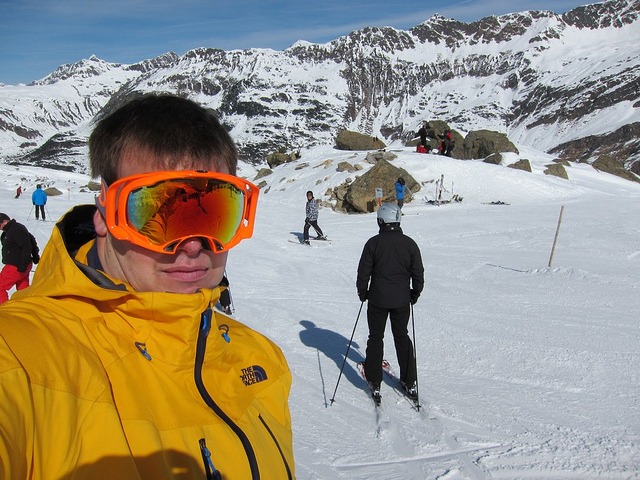Please identify all text content in this image. THE 